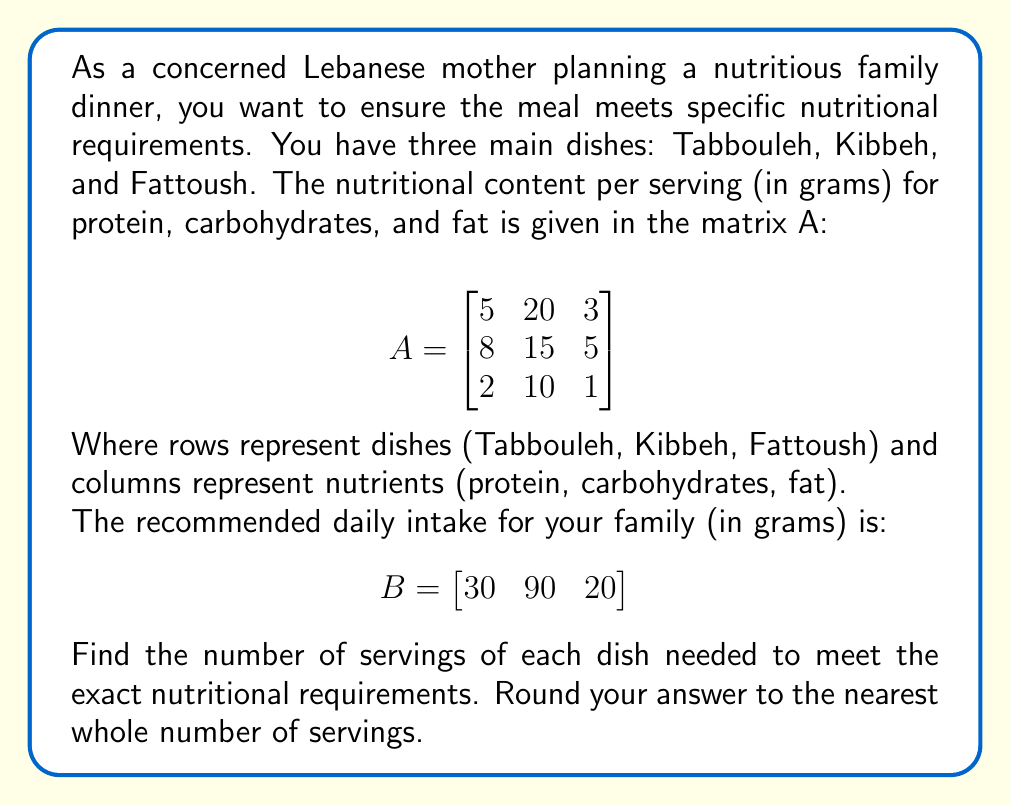Solve this math problem. To solve this problem, we need to find a vector X that satisfies the equation AX = B, where X represents the number of servings of each dish.

Step 1: Set up the equation
$$\begin{bmatrix}
5 & 20 & 3 \\
8 & 15 & 5 \\
2 & 10 & 1
\end{bmatrix} \begin{bmatrix}
x_1 \\
x_2 \\
x_3
\end{bmatrix} = \begin{bmatrix}
30 \\
90 \\
20
\end{bmatrix}$$

Step 2: Solve the system of equations
To solve this, we can use the inverse matrix method: X = A^(-1)B

First, calculate the inverse of A:
$$A^{-1} = \frac{1}{55}\begin{bmatrix}
-5 & 10 & -15 \\
4 & -1 & 1 \\
-3 & -5 & 40
\end{bmatrix}$$

Step 3: Multiply A^(-1) by B
$$X = \frac{1}{55}\begin{bmatrix}
-5 & 10 & -15 \\
4 & -1 & 1 \\
-3 & -5 & 40
\end{bmatrix} \begin{bmatrix}
30 \\
90 \\
20
\end{bmatrix}$$

$$X = \begin{bmatrix}
2.27 \\
3.64 \\
1.09
\end{bmatrix}$$

Step 4: Round to the nearest whole number
$$X \approx \begin{bmatrix}
2 \\
4 \\
1
\end{bmatrix}$$
Answer: 2 servings of Tabbouleh, 4 servings of Kibbeh, and 1 serving of Fattoush 